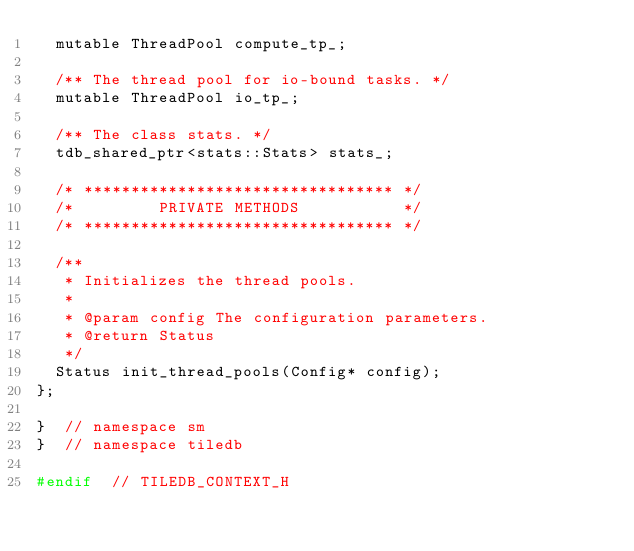<code> <loc_0><loc_0><loc_500><loc_500><_C_>  mutable ThreadPool compute_tp_;

  /** The thread pool for io-bound tasks. */
  mutable ThreadPool io_tp_;

  /** The class stats. */
  tdb_shared_ptr<stats::Stats> stats_;

  /* ********************************* */
  /*         PRIVATE METHODS           */
  /* ********************************* */

  /**
   * Initializes the thread pools.
   *
   * @param config The configuration parameters.
   * @return Status
   */
  Status init_thread_pools(Config* config);
};

}  // namespace sm
}  // namespace tiledb

#endif  // TILEDB_CONTEXT_H
</code> 